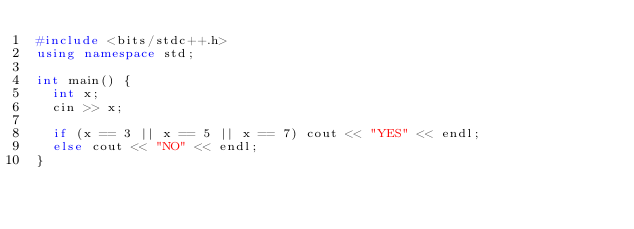Convert code to text. <code><loc_0><loc_0><loc_500><loc_500><_C++_>#include <bits/stdc++.h>
using namespace std;

int main() {
  int x;
  cin >> x;
  
  if (x == 3 || x == 5 || x == 7) cout << "YES" << endl;
  else cout << "NO" << endl;
}
</code> 